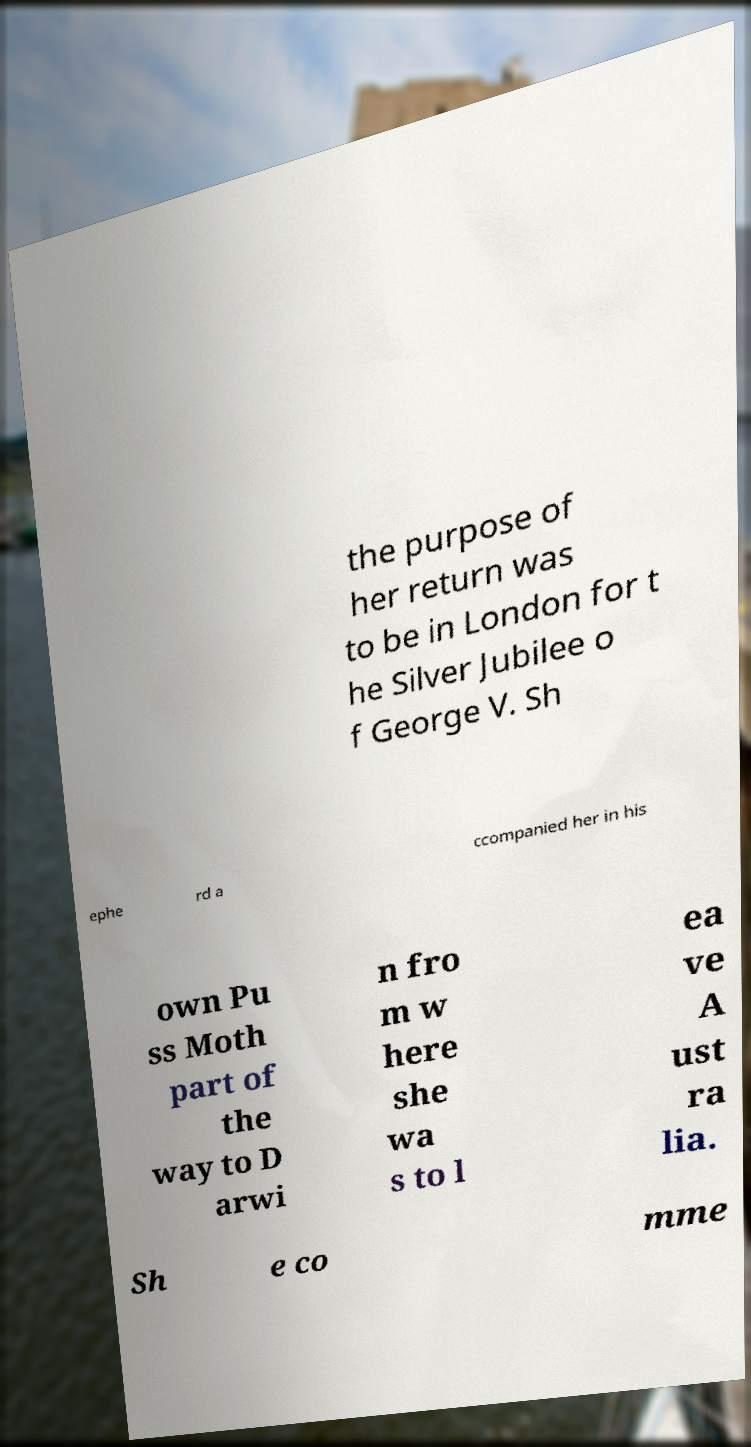Could you extract and type out the text from this image? the purpose of her return was to be in London for t he Silver Jubilee o f George V. Sh ephe rd a ccompanied her in his own Pu ss Moth part of the way to D arwi n fro m w here she wa s to l ea ve A ust ra lia. Sh e co mme 